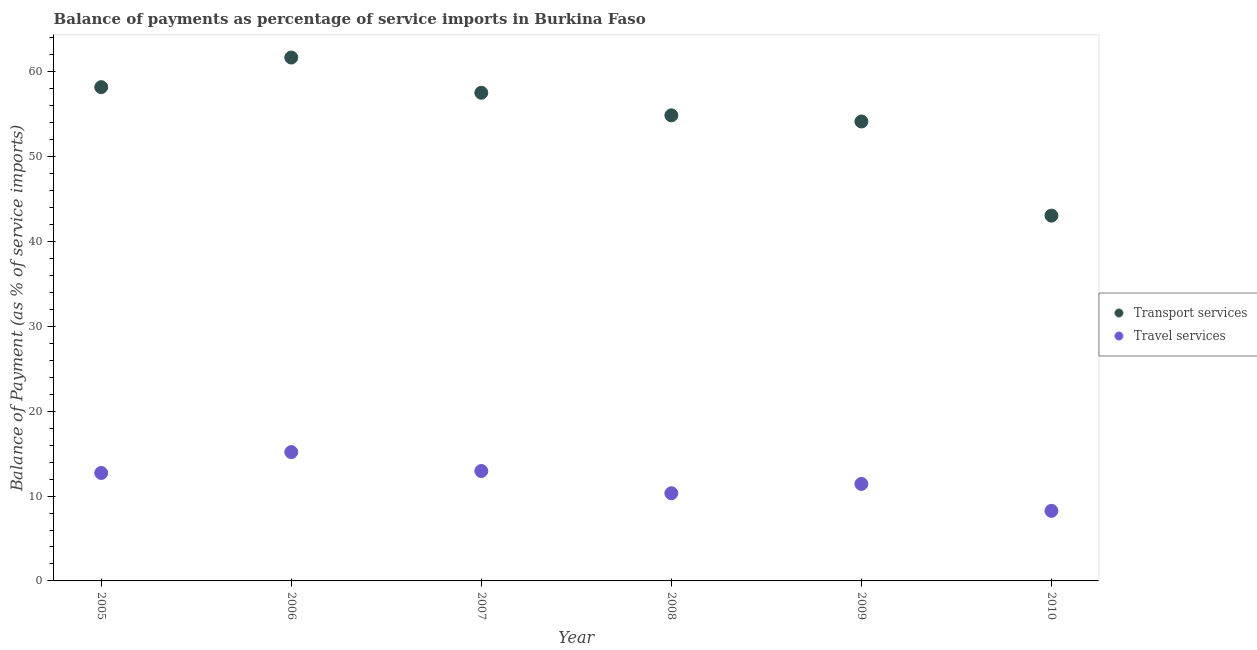How many different coloured dotlines are there?
Provide a short and direct response. 2. What is the balance of payments of travel services in 2008?
Provide a succinct answer. 10.33. Across all years, what is the maximum balance of payments of travel services?
Offer a very short reply. 15.18. Across all years, what is the minimum balance of payments of travel services?
Provide a succinct answer. 8.26. In which year was the balance of payments of travel services minimum?
Ensure brevity in your answer.  2010. What is the total balance of payments of transport services in the graph?
Offer a very short reply. 329.47. What is the difference between the balance of payments of transport services in 2006 and that in 2010?
Your answer should be compact. 18.63. What is the difference between the balance of payments of travel services in 2008 and the balance of payments of transport services in 2009?
Ensure brevity in your answer.  -43.81. What is the average balance of payments of travel services per year?
Your answer should be very brief. 11.81. In the year 2009, what is the difference between the balance of payments of transport services and balance of payments of travel services?
Provide a short and direct response. 42.71. What is the ratio of the balance of payments of transport services in 2005 to that in 2009?
Ensure brevity in your answer.  1.07. What is the difference between the highest and the second highest balance of payments of transport services?
Provide a succinct answer. 3.49. What is the difference between the highest and the lowest balance of payments of transport services?
Provide a short and direct response. 18.63. Does the balance of payments of transport services monotonically increase over the years?
Make the answer very short. No. How many dotlines are there?
Your response must be concise. 2. Are the values on the major ticks of Y-axis written in scientific E-notation?
Your answer should be compact. No. Does the graph contain grids?
Provide a succinct answer. No. What is the title of the graph?
Make the answer very short. Balance of payments as percentage of service imports in Burkina Faso. Does "External balance on goods" appear as one of the legend labels in the graph?
Ensure brevity in your answer.  No. What is the label or title of the X-axis?
Keep it short and to the point. Year. What is the label or title of the Y-axis?
Provide a short and direct response. Balance of Payment (as % of service imports). What is the Balance of Payment (as % of service imports) of Transport services in 2005?
Provide a succinct answer. 58.19. What is the Balance of Payment (as % of service imports) in Travel services in 2005?
Make the answer very short. 12.73. What is the Balance of Payment (as % of service imports) in Transport services in 2006?
Offer a very short reply. 61.68. What is the Balance of Payment (as % of service imports) in Travel services in 2006?
Make the answer very short. 15.18. What is the Balance of Payment (as % of service imports) of Transport services in 2007?
Your response must be concise. 57.53. What is the Balance of Payment (as % of service imports) in Travel services in 2007?
Offer a very short reply. 12.95. What is the Balance of Payment (as % of service imports) in Transport services in 2008?
Provide a succinct answer. 54.87. What is the Balance of Payment (as % of service imports) of Travel services in 2008?
Provide a succinct answer. 10.33. What is the Balance of Payment (as % of service imports) in Transport services in 2009?
Offer a very short reply. 54.15. What is the Balance of Payment (as % of service imports) in Travel services in 2009?
Provide a short and direct response. 11.43. What is the Balance of Payment (as % of service imports) of Transport services in 2010?
Make the answer very short. 43.05. What is the Balance of Payment (as % of service imports) of Travel services in 2010?
Provide a short and direct response. 8.26. Across all years, what is the maximum Balance of Payment (as % of service imports) in Transport services?
Your response must be concise. 61.68. Across all years, what is the maximum Balance of Payment (as % of service imports) in Travel services?
Give a very brief answer. 15.18. Across all years, what is the minimum Balance of Payment (as % of service imports) in Transport services?
Give a very brief answer. 43.05. Across all years, what is the minimum Balance of Payment (as % of service imports) in Travel services?
Offer a very short reply. 8.26. What is the total Balance of Payment (as % of service imports) of Transport services in the graph?
Offer a terse response. 329.47. What is the total Balance of Payment (as % of service imports) in Travel services in the graph?
Offer a terse response. 70.89. What is the difference between the Balance of Payment (as % of service imports) of Transport services in 2005 and that in 2006?
Keep it short and to the point. -3.49. What is the difference between the Balance of Payment (as % of service imports) of Travel services in 2005 and that in 2006?
Make the answer very short. -2.46. What is the difference between the Balance of Payment (as % of service imports) of Transport services in 2005 and that in 2007?
Offer a terse response. 0.66. What is the difference between the Balance of Payment (as % of service imports) of Travel services in 2005 and that in 2007?
Provide a succinct answer. -0.23. What is the difference between the Balance of Payment (as % of service imports) in Transport services in 2005 and that in 2008?
Your answer should be compact. 3.33. What is the difference between the Balance of Payment (as % of service imports) in Travel services in 2005 and that in 2008?
Keep it short and to the point. 2.39. What is the difference between the Balance of Payment (as % of service imports) of Transport services in 2005 and that in 2009?
Your response must be concise. 4.05. What is the difference between the Balance of Payment (as % of service imports) in Travel services in 2005 and that in 2009?
Offer a very short reply. 1.29. What is the difference between the Balance of Payment (as % of service imports) in Transport services in 2005 and that in 2010?
Your answer should be compact. 15.14. What is the difference between the Balance of Payment (as % of service imports) of Travel services in 2005 and that in 2010?
Make the answer very short. 4.47. What is the difference between the Balance of Payment (as % of service imports) of Transport services in 2006 and that in 2007?
Offer a very short reply. 4.15. What is the difference between the Balance of Payment (as % of service imports) in Travel services in 2006 and that in 2007?
Give a very brief answer. 2.23. What is the difference between the Balance of Payment (as % of service imports) in Transport services in 2006 and that in 2008?
Give a very brief answer. 6.81. What is the difference between the Balance of Payment (as % of service imports) of Travel services in 2006 and that in 2008?
Your answer should be compact. 4.85. What is the difference between the Balance of Payment (as % of service imports) in Transport services in 2006 and that in 2009?
Offer a terse response. 7.53. What is the difference between the Balance of Payment (as % of service imports) of Travel services in 2006 and that in 2009?
Your answer should be compact. 3.75. What is the difference between the Balance of Payment (as % of service imports) in Transport services in 2006 and that in 2010?
Your answer should be very brief. 18.63. What is the difference between the Balance of Payment (as % of service imports) in Travel services in 2006 and that in 2010?
Give a very brief answer. 6.93. What is the difference between the Balance of Payment (as % of service imports) in Transport services in 2007 and that in 2008?
Offer a very short reply. 2.66. What is the difference between the Balance of Payment (as % of service imports) in Travel services in 2007 and that in 2008?
Offer a terse response. 2.62. What is the difference between the Balance of Payment (as % of service imports) in Transport services in 2007 and that in 2009?
Provide a succinct answer. 3.38. What is the difference between the Balance of Payment (as % of service imports) of Travel services in 2007 and that in 2009?
Your answer should be very brief. 1.52. What is the difference between the Balance of Payment (as % of service imports) in Transport services in 2007 and that in 2010?
Your response must be concise. 14.48. What is the difference between the Balance of Payment (as % of service imports) of Travel services in 2007 and that in 2010?
Your answer should be very brief. 4.7. What is the difference between the Balance of Payment (as % of service imports) of Transport services in 2008 and that in 2009?
Ensure brevity in your answer.  0.72. What is the difference between the Balance of Payment (as % of service imports) in Travel services in 2008 and that in 2009?
Provide a short and direct response. -1.1. What is the difference between the Balance of Payment (as % of service imports) in Transport services in 2008 and that in 2010?
Your answer should be very brief. 11.82. What is the difference between the Balance of Payment (as % of service imports) of Travel services in 2008 and that in 2010?
Your response must be concise. 2.08. What is the difference between the Balance of Payment (as % of service imports) in Transport services in 2009 and that in 2010?
Your answer should be compact. 11.1. What is the difference between the Balance of Payment (as % of service imports) in Travel services in 2009 and that in 2010?
Ensure brevity in your answer.  3.18. What is the difference between the Balance of Payment (as % of service imports) in Transport services in 2005 and the Balance of Payment (as % of service imports) in Travel services in 2006?
Your answer should be very brief. 43.01. What is the difference between the Balance of Payment (as % of service imports) in Transport services in 2005 and the Balance of Payment (as % of service imports) in Travel services in 2007?
Your response must be concise. 45.24. What is the difference between the Balance of Payment (as % of service imports) in Transport services in 2005 and the Balance of Payment (as % of service imports) in Travel services in 2008?
Provide a short and direct response. 47.86. What is the difference between the Balance of Payment (as % of service imports) in Transport services in 2005 and the Balance of Payment (as % of service imports) in Travel services in 2009?
Give a very brief answer. 46.76. What is the difference between the Balance of Payment (as % of service imports) in Transport services in 2005 and the Balance of Payment (as % of service imports) in Travel services in 2010?
Your response must be concise. 49.94. What is the difference between the Balance of Payment (as % of service imports) in Transport services in 2006 and the Balance of Payment (as % of service imports) in Travel services in 2007?
Ensure brevity in your answer.  48.73. What is the difference between the Balance of Payment (as % of service imports) in Transport services in 2006 and the Balance of Payment (as % of service imports) in Travel services in 2008?
Your answer should be very brief. 51.35. What is the difference between the Balance of Payment (as % of service imports) of Transport services in 2006 and the Balance of Payment (as % of service imports) of Travel services in 2009?
Provide a succinct answer. 50.25. What is the difference between the Balance of Payment (as % of service imports) of Transport services in 2006 and the Balance of Payment (as % of service imports) of Travel services in 2010?
Give a very brief answer. 53.42. What is the difference between the Balance of Payment (as % of service imports) of Transport services in 2007 and the Balance of Payment (as % of service imports) of Travel services in 2008?
Ensure brevity in your answer.  47.2. What is the difference between the Balance of Payment (as % of service imports) of Transport services in 2007 and the Balance of Payment (as % of service imports) of Travel services in 2009?
Provide a succinct answer. 46.1. What is the difference between the Balance of Payment (as % of service imports) in Transport services in 2007 and the Balance of Payment (as % of service imports) in Travel services in 2010?
Provide a short and direct response. 49.27. What is the difference between the Balance of Payment (as % of service imports) of Transport services in 2008 and the Balance of Payment (as % of service imports) of Travel services in 2009?
Provide a succinct answer. 43.43. What is the difference between the Balance of Payment (as % of service imports) in Transport services in 2008 and the Balance of Payment (as % of service imports) in Travel services in 2010?
Your answer should be compact. 46.61. What is the difference between the Balance of Payment (as % of service imports) in Transport services in 2009 and the Balance of Payment (as % of service imports) in Travel services in 2010?
Keep it short and to the point. 45.89. What is the average Balance of Payment (as % of service imports) in Transport services per year?
Your response must be concise. 54.91. What is the average Balance of Payment (as % of service imports) of Travel services per year?
Keep it short and to the point. 11.81. In the year 2005, what is the difference between the Balance of Payment (as % of service imports) of Transport services and Balance of Payment (as % of service imports) of Travel services?
Give a very brief answer. 45.47. In the year 2006, what is the difference between the Balance of Payment (as % of service imports) in Transport services and Balance of Payment (as % of service imports) in Travel services?
Make the answer very short. 46.5. In the year 2007, what is the difference between the Balance of Payment (as % of service imports) in Transport services and Balance of Payment (as % of service imports) in Travel services?
Offer a terse response. 44.58. In the year 2008, what is the difference between the Balance of Payment (as % of service imports) in Transport services and Balance of Payment (as % of service imports) in Travel services?
Ensure brevity in your answer.  44.53. In the year 2009, what is the difference between the Balance of Payment (as % of service imports) in Transport services and Balance of Payment (as % of service imports) in Travel services?
Make the answer very short. 42.71. In the year 2010, what is the difference between the Balance of Payment (as % of service imports) in Transport services and Balance of Payment (as % of service imports) in Travel services?
Your response must be concise. 34.79. What is the ratio of the Balance of Payment (as % of service imports) of Transport services in 2005 to that in 2006?
Your response must be concise. 0.94. What is the ratio of the Balance of Payment (as % of service imports) of Travel services in 2005 to that in 2006?
Provide a short and direct response. 0.84. What is the ratio of the Balance of Payment (as % of service imports) in Transport services in 2005 to that in 2007?
Keep it short and to the point. 1.01. What is the ratio of the Balance of Payment (as % of service imports) in Travel services in 2005 to that in 2007?
Your answer should be very brief. 0.98. What is the ratio of the Balance of Payment (as % of service imports) of Transport services in 2005 to that in 2008?
Ensure brevity in your answer.  1.06. What is the ratio of the Balance of Payment (as % of service imports) in Travel services in 2005 to that in 2008?
Ensure brevity in your answer.  1.23. What is the ratio of the Balance of Payment (as % of service imports) in Transport services in 2005 to that in 2009?
Provide a succinct answer. 1.07. What is the ratio of the Balance of Payment (as % of service imports) of Travel services in 2005 to that in 2009?
Give a very brief answer. 1.11. What is the ratio of the Balance of Payment (as % of service imports) of Transport services in 2005 to that in 2010?
Ensure brevity in your answer.  1.35. What is the ratio of the Balance of Payment (as % of service imports) in Travel services in 2005 to that in 2010?
Ensure brevity in your answer.  1.54. What is the ratio of the Balance of Payment (as % of service imports) in Transport services in 2006 to that in 2007?
Your answer should be compact. 1.07. What is the ratio of the Balance of Payment (as % of service imports) in Travel services in 2006 to that in 2007?
Give a very brief answer. 1.17. What is the ratio of the Balance of Payment (as % of service imports) of Transport services in 2006 to that in 2008?
Provide a succinct answer. 1.12. What is the ratio of the Balance of Payment (as % of service imports) of Travel services in 2006 to that in 2008?
Ensure brevity in your answer.  1.47. What is the ratio of the Balance of Payment (as % of service imports) of Transport services in 2006 to that in 2009?
Offer a very short reply. 1.14. What is the ratio of the Balance of Payment (as % of service imports) of Travel services in 2006 to that in 2009?
Offer a very short reply. 1.33. What is the ratio of the Balance of Payment (as % of service imports) of Transport services in 2006 to that in 2010?
Keep it short and to the point. 1.43. What is the ratio of the Balance of Payment (as % of service imports) of Travel services in 2006 to that in 2010?
Keep it short and to the point. 1.84. What is the ratio of the Balance of Payment (as % of service imports) of Transport services in 2007 to that in 2008?
Provide a short and direct response. 1.05. What is the ratio of the Balance of Payment (as % of service imports) of Travel services in 2007 to that in 2008?
Your answer should be compact. 1.25. What is the ratio of the Balance of Payment (as % of service imports) in Travel services in 2007 to that in 2009?
Make the answer very short. 1.13. What is the ratio of the Balance of Payment (as % of service imports) in Transport services in 2007 to that in 2010?
Provide a succinct answer. 1.34. What is the ratio of the Balance of Payment (as % of service imports) in Travel services in 2007 to that in 2010?
Keep it short and to the point. 1.57. What is the ratio of the Balance of Payment (as % of service imports) of Transport services in 2008 to that in 2009?
Your answer should be very brief. 1.01. What is the ratio of the Balance of Payment (as % of service imports) in Travel services in 2008 to that in 2009?
Your answer should be compact. 0.9. What is the ratio of the Balance of Payment (as % of service imports) in Transport services in 2008 to that in 2010?
Ensure brevity in your answer.  1.27. What is the ratio of the Balance of Payment (as % of service imports) in Travel services in 2008 to that in 2010?
Give a very brief answer. 1.25. What is the ratio of the Balance of Payment (as % of service imports) in Transport services in 2009 to that in 2010?
Your answer should be compact. 1.26. What is the ratio of the Balance of Payment (as % of service imports) in Travel services in 2009 to that in 2010?
Your answer should be compact. 1.38. What is the difference between the highest and the second highest Balance of Payment (as % of service imports) in Transport services?
Your answer should be compact. 3.49. What is the difference between the highest and the second highest Balance of Payment (as % of service imports) of Travel services?
Your answer should be compact. 2.23. What is the difference between the highest and the lowest Balance of Payment (as % of service imports) in Transport services?
Offer a very short reply. 18.63. What is the difference between the highest and the lowest Balance of Payment (as % of service imports) in Travel services?
Make the answer very short. 6.93. 